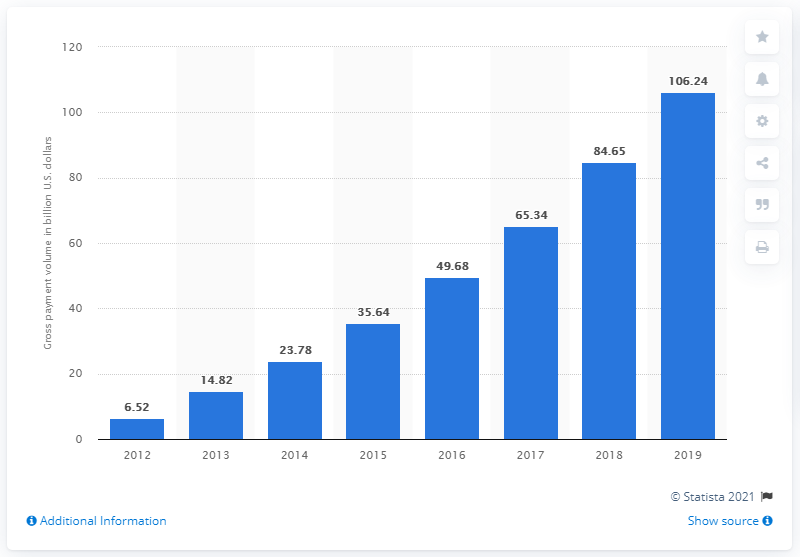Highlight a few significant elements in this photo. In the most recent fiscal period, Square's gross payment volume was 106.24. In 2018, Square's gross payment volume was 84.65. 